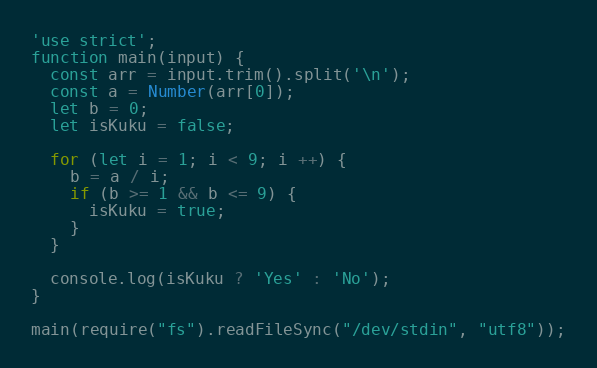Convert code to text. <code><loc_0><loc_0><loc_500><loc_500><_JavaScript_>'use strict';
function main(input) {
  const arr = input.trim().split('\n');
  const a = Number(arr[0]);
  let b = 0;
  let isKuku = false;

  for (let i = 1; i < 9; i ++) {
    b = a / i;
    if (b >= 1 && b <= 9) {
      isKuku = true;
    }
  }
  
  console.log(isKuku ? 'Yes' : 'No');
}

main(require("fs").readFileSync("/dev/stdin", "utf8"));</code> 